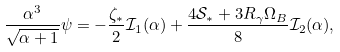Convert formula to latex. <formula><loc_0><loc_0><loc_500><loc_500>\frac { \alpha ^ { 3 } } { \sqrt { \alpha + 1 } } \psi = - \frac { \zeta _ { * } } { 2 } { \mathcal { I } } _ { 1 } ( \alpha ) + \frac { 4 { \mathcal { S } } _ { * } + 3 R _ { \gamma } \Omega _ { B } } { 8 } { \mathcal { I } } _ { 2 } ( \alpha ) ,</formula> 